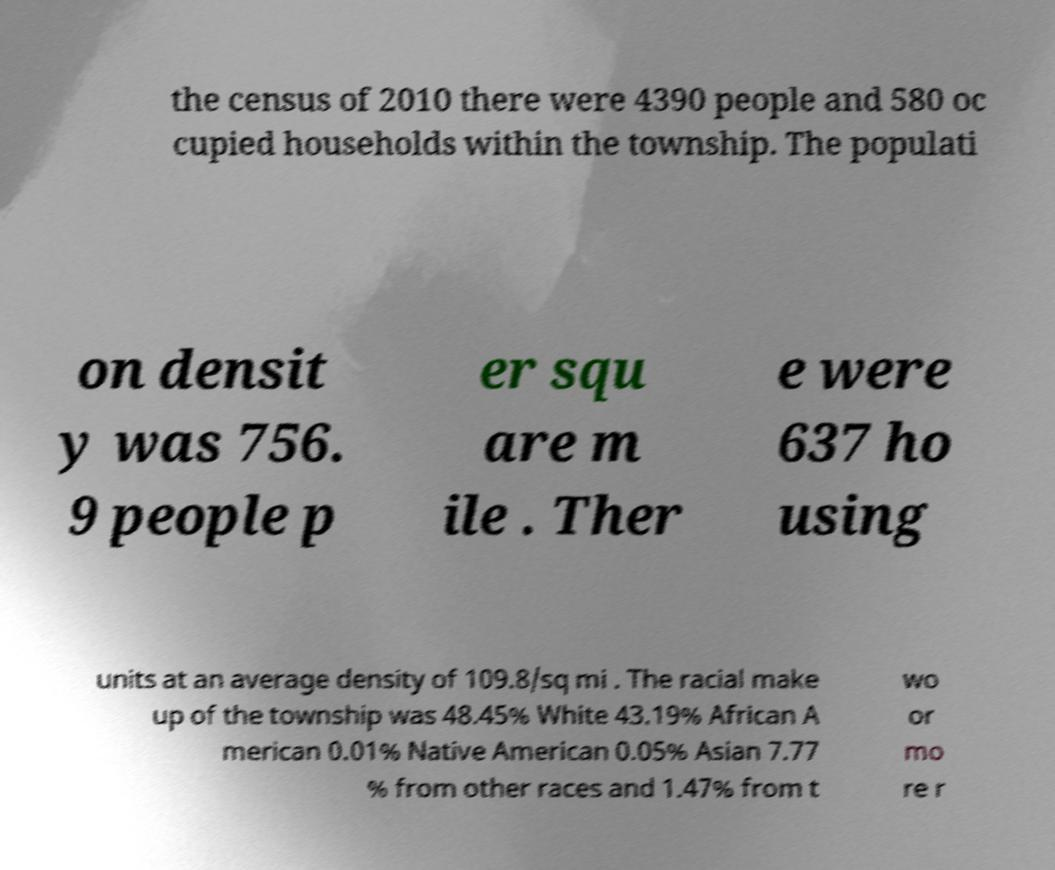Can you read and provide the text displayed in the image?This photo seems to have some interesting text. Can you extract and type it out for me? the census of 2010 there were 4390 people and 580 oc cupied households within the township. The populati on densit y was 756. 9 people p er squ are m ile . Ther e were 637 ho using units at an average density of 109.8/sq mi . The racial make up of the township was 48.45% White 43.19% African A merican 0.01% Native American 0.05% Asian 7.77 % from other races and 1.47% from t wo or mo re r 